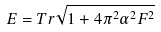<formula> <loc_0><loc_0><loc_500><loc_500>E = T r \sqrt { 1 + 4 \pi ^ { 2 } \alpha ^ { 2 } F ^ { 2 } }</formula> 